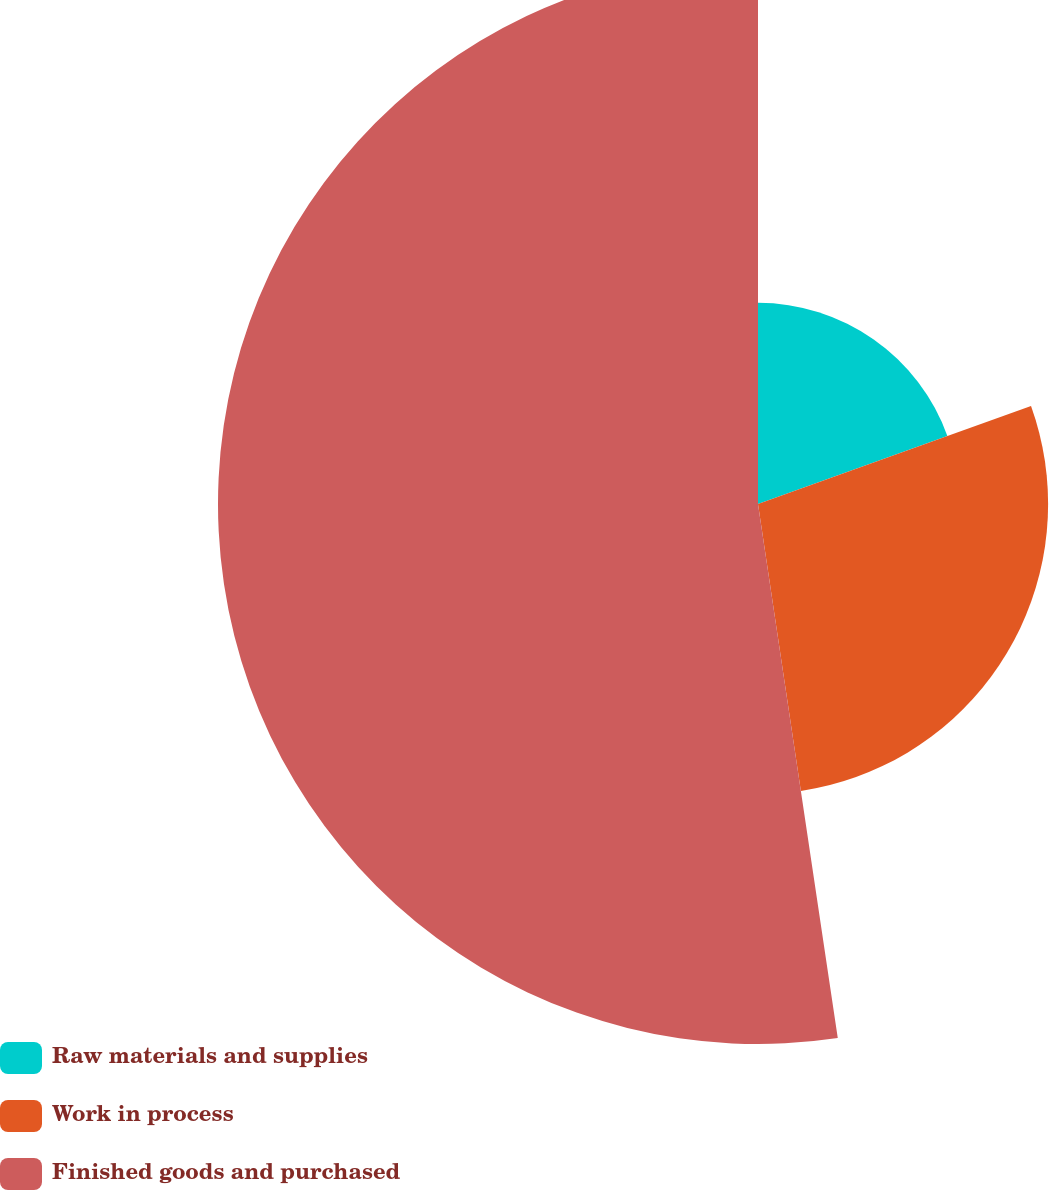Convert chart to OTSL. <chart><loc_0><loc_0><loc_500><loc_500><pie_chart><fcel>Raw materials and supplies<fcel>Work in process<fcel>Finished goods and purchased<nl><fcel>19.51%<fcel>28.13%<fcel>52.36%<nl></chart> 